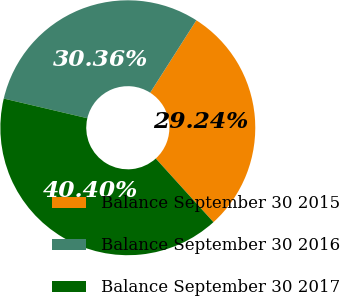Convert chart. <chart><loc_0><loc_0><loc_500><loc_500><pie_chart><fcel>Balance September 30 2015<fcel>Balance September 30 2016<fcel>Balance September 30 2017<nl><fcel>29.24%<fcel>30.36%<fcel>40.4%<nl></chart> 